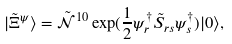<formula> <loc_0><loc_0><loc_500><loc_500>| \tilde { \Xi } ^ { \psi } \rangle = \tilde { \mathcal { N } } ^ { 1 0 } \exp ( \frac { 1 } { 2 } \psi ^ { \dag } _ { r } \tilde { S } _ { r s } \psi ^ { \dag } _ { s } ) | 0 \rangle ,</formula> 